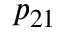<formula> <loc_0><loc_0><loc_500><loc_500>p _ { 2 1 }</formula> 